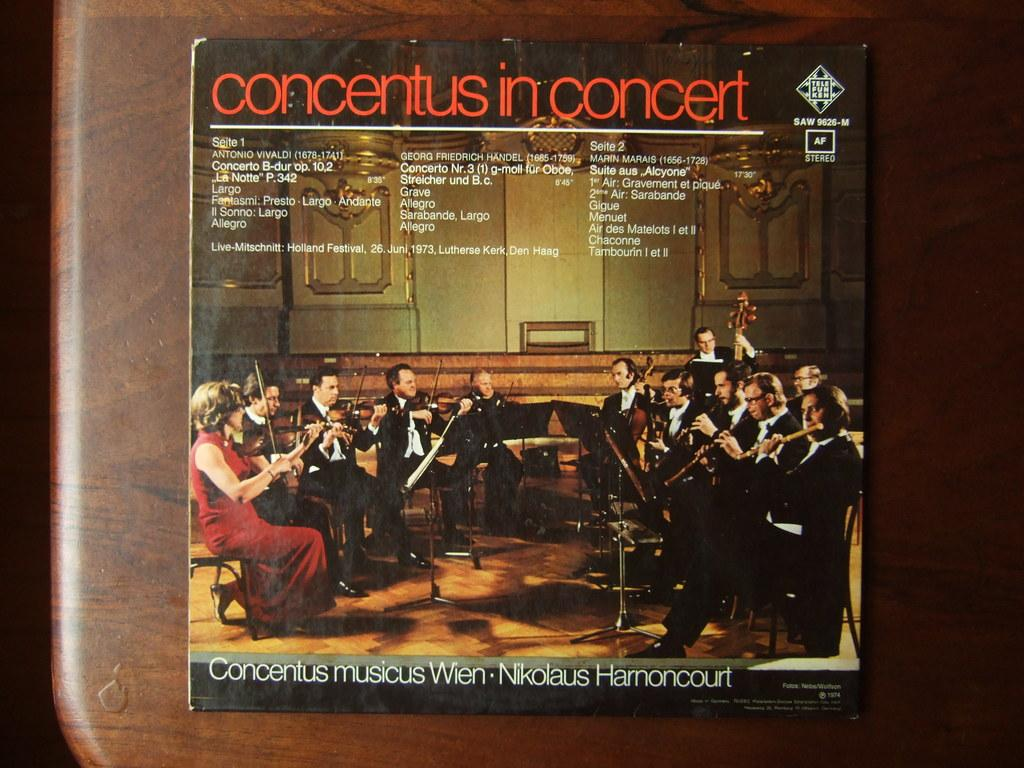<image>
Describe the image concisely. Concentus in Concert features an orchestra on the cover. 